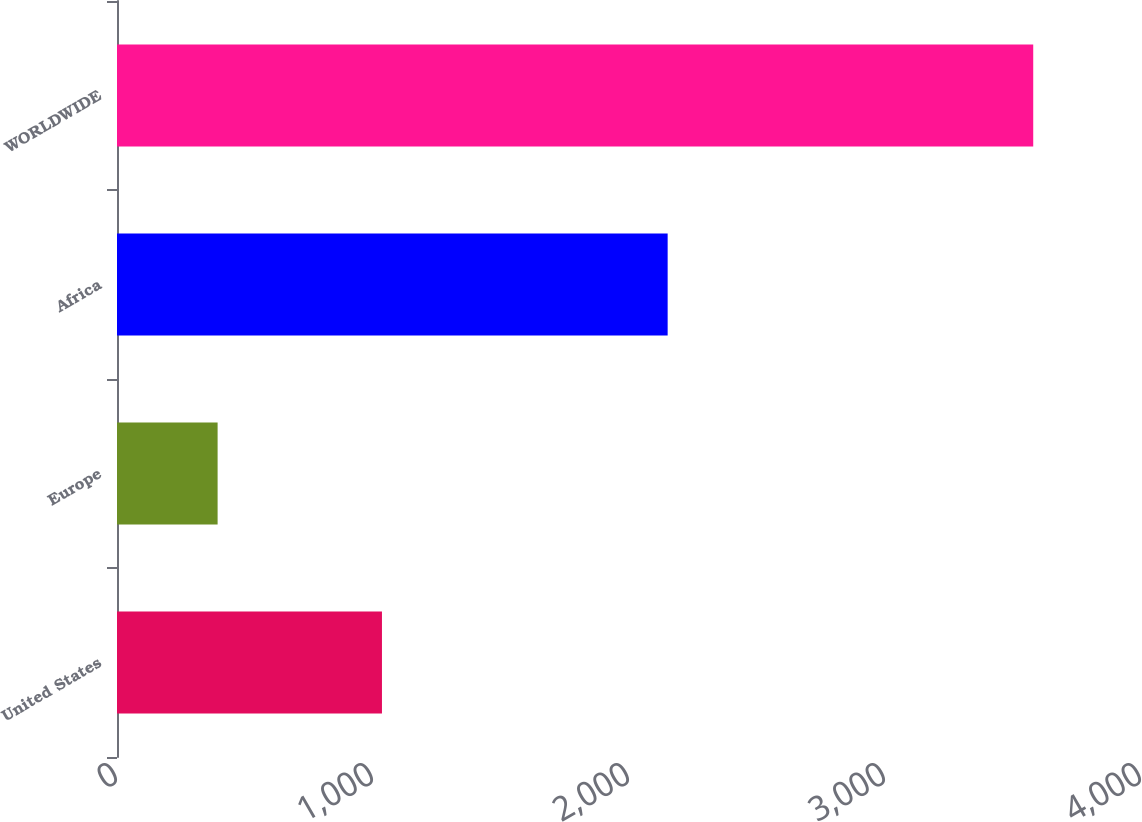Convert chart to OTSL. <chart><loc_0><loc_0><loc_500><loc_500><bar_chart><fcel>United States<fcel>Europe<fcel>Africa<fcel>WORLDWIDE<nl><fcel>1035<fcel>393<fcel>2151<fcel>3579<nl></chart> 